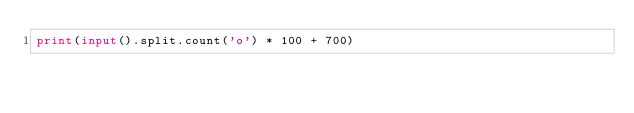Convert code to text. <code><loc_0><loc_0><loc_500><loc_500><_Python_>print(input().split.count('o') * 100 + 700)</code> 